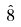Convert formula to latex. <formula><loc_0><loc_0><loc_500><loc_500>\hat { 8 }</formula> 